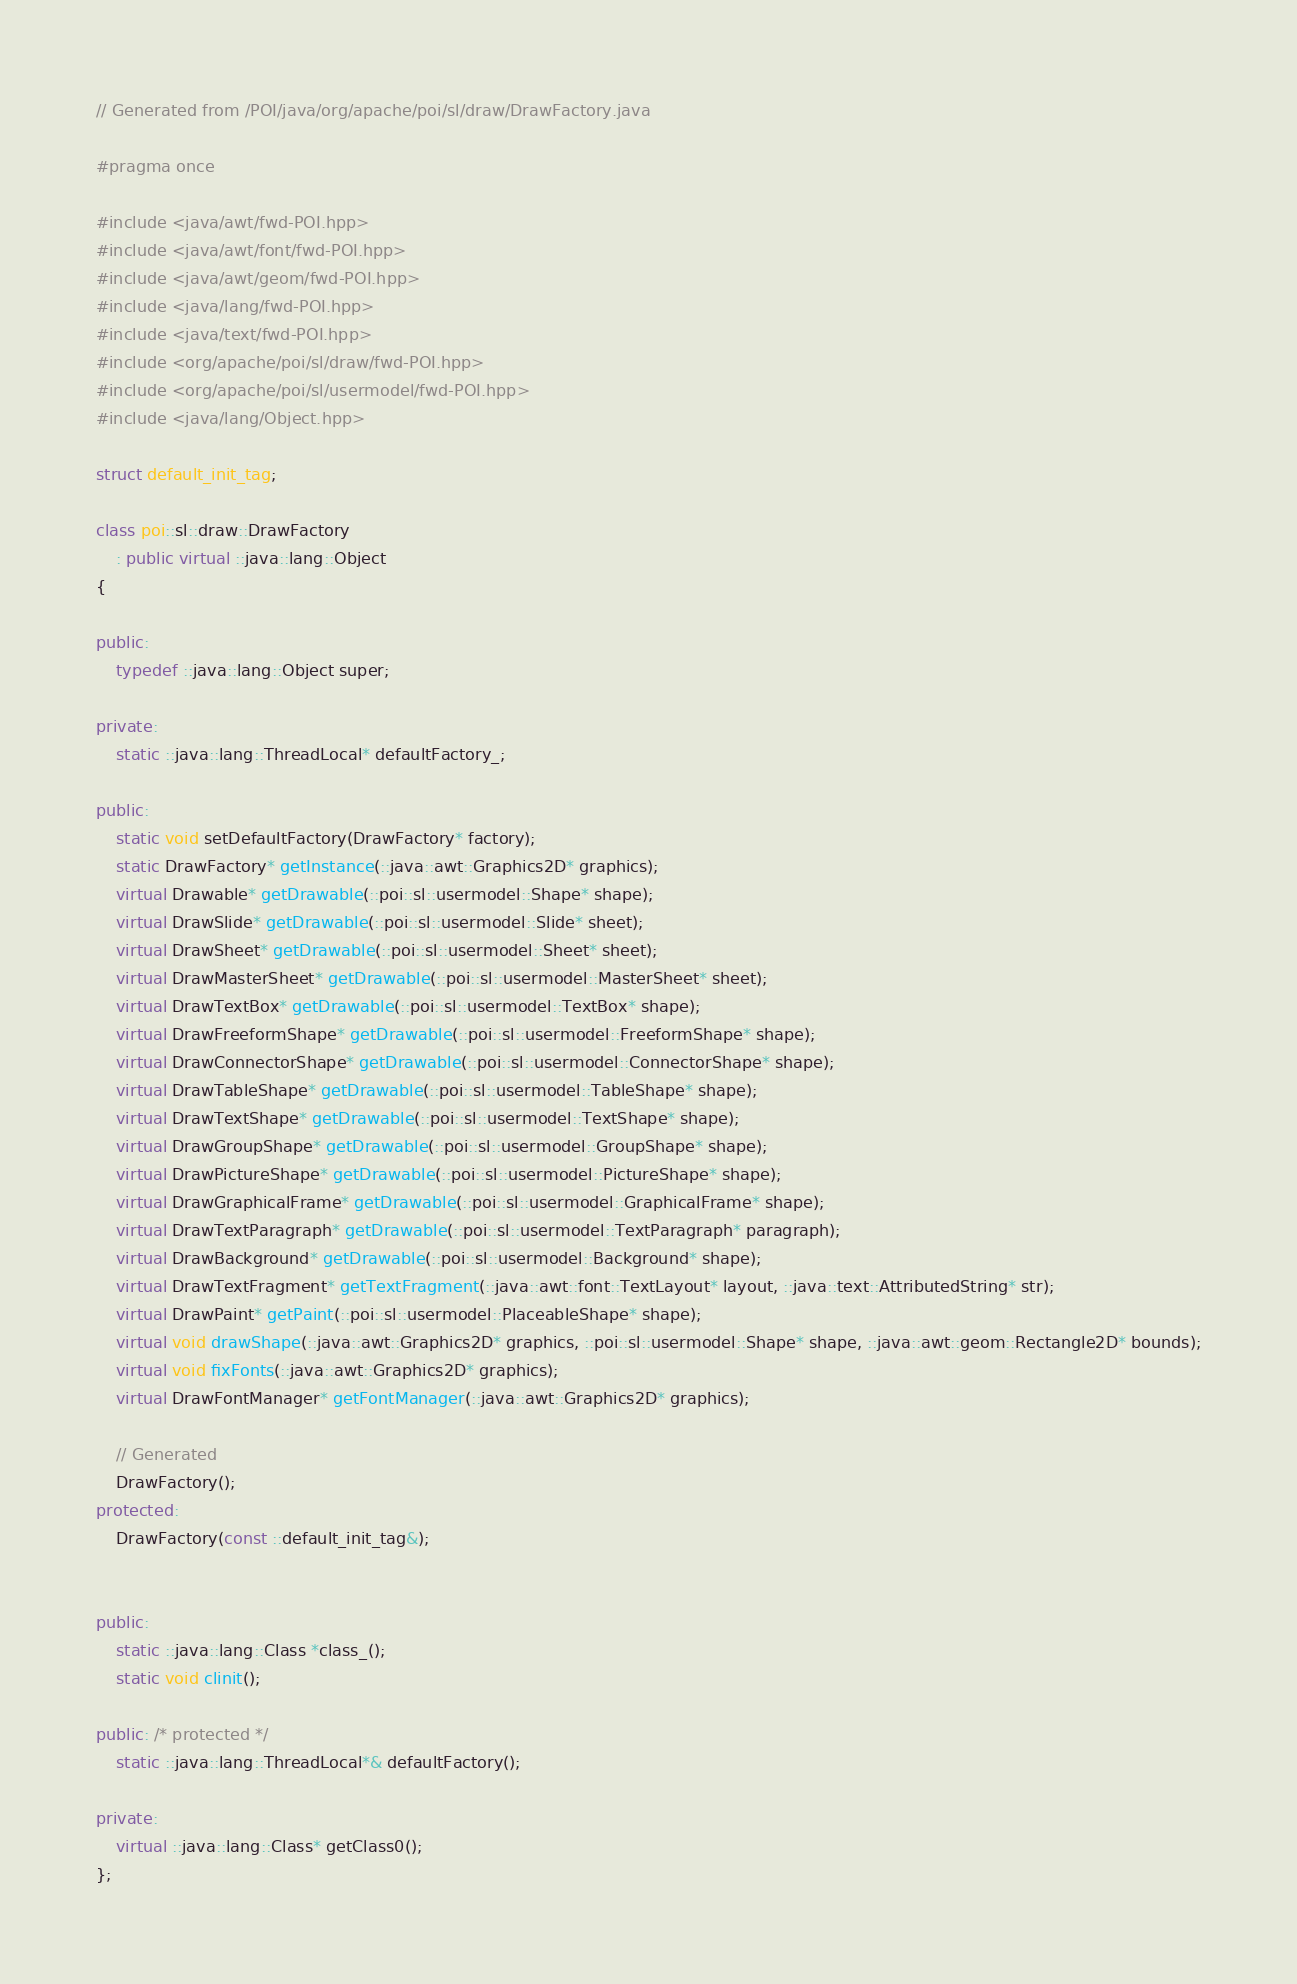Convert code to text. <code><loc_0><loc_0><loc_500><loc_500><_C++_>// Generated from /POI/java/org/apache/poi/sl/draw/DrawFactory.java

#pragma once

#include <java/awt/fwd-POI.hpp>
#include <java/awt/font/fwd-POI.hpp>
#include <java/awt/geom/fwd-POI.hpp>
#include <java/lang/fwd-POI.hpp>
#include <java/text/fwd-POI.hpp>
#include <org/apache/poi/sl/draw/fwd-POI.hpp>
#include <org/apache/poi/sl/usermodel/fwd-POI.hpp>
#include <java/lang/Object.hpp>

struct default_init_tag;

class poi::sl::draw::DrawFactory
    : public virtual ::java::lang::Object
{

public:
    typedef ::java::lang::Object super;

private:
    static ::java::lang::ThreadLocal* defaultFactory_;

public:
    static void setDefaultFactory(DrawFactory* factory);
    static DrawFactory* getInstance(::java::awt::Graphics2D* graphics);
    virtual Drawable* getDrawable(::poi::sl::usermodel::Shape* shape);
    virtual DrawSlide* getDrawable(::poi::sl::usermodel::Slide* sheet);
    virtual DrawSheet* getDrawable(::poi::sl::usermodel::Sheet* sheet);
    virtual DrawMasterSheet* getDrawable(::poi::sl::usermodel::MasterSheet* sheet);
    virtual DrawTextBox* getDrawable(::poi::sl::usermodel::TextBox* shape);
    virtual DrawFreeformShape* getDrawable(::poi::sl::usermodel::FreeformShape* shape);
    virtual DrawConnectorShape* getDrawable(::poi::sl::usermodel::ConnectorShape* shape);
    virtual DrawTableShape* getDrawable(::poi::sl::usermodel::TableShape* shape);
    virtual DrawTextShape* getDrawable(::poi::sl::usermodel::TextShape* shape);
    virtual DrawGroupShape* getDrawable(::poi::sl::usermodel::GroupShape* shape);
    virtual DrawPictureShape* getDrawable(::poi::sl::usermodel::PictureShape* shape);
    virtual DrawGraphicalFrame* getDrawable(::poi::sl::usermodel::GraphicalFrame* shape);
    virtual DrawTextParagraph* getDrawable(::poi::sl::usermodel::TextParagraph* paragraph);
    virtual DrawBackground* getDrawable(::poi::sl::usermodel::Background* shape);
    virtual DrawTextFragment* getTextFragment(::java::awt::font::TextLayout* layout, ::java::text::AttributedString* str);
    virtual DrawPaint* getPaint(::poi::sl::usermodel::PlaceableShape* shape);
    virtual void drawShape(::java::awt::Graphics2D* graphics, ::poi::sl::usermodel::Shape* shape, ::java::awt::geom::Rectangle2D* bounds);
    virtual void fixFonts(::java::awt::Graphics2D* graphics);
    virtual DrawFontManager* getFontManager(::java::awt::Graphics2D* graphics);

    // Generated
    DrawFactory();
protected:
    DrawFactory(const ::default_init_tag&);


public:
    static ::java::lang::Class *class_();
    static void clinit();

public: /* protected */
    static ::java::lang::ThreadLocal*& defaultFactory();

private:
    virtual ::java::lang::Class* getClass0();
};
</code> 